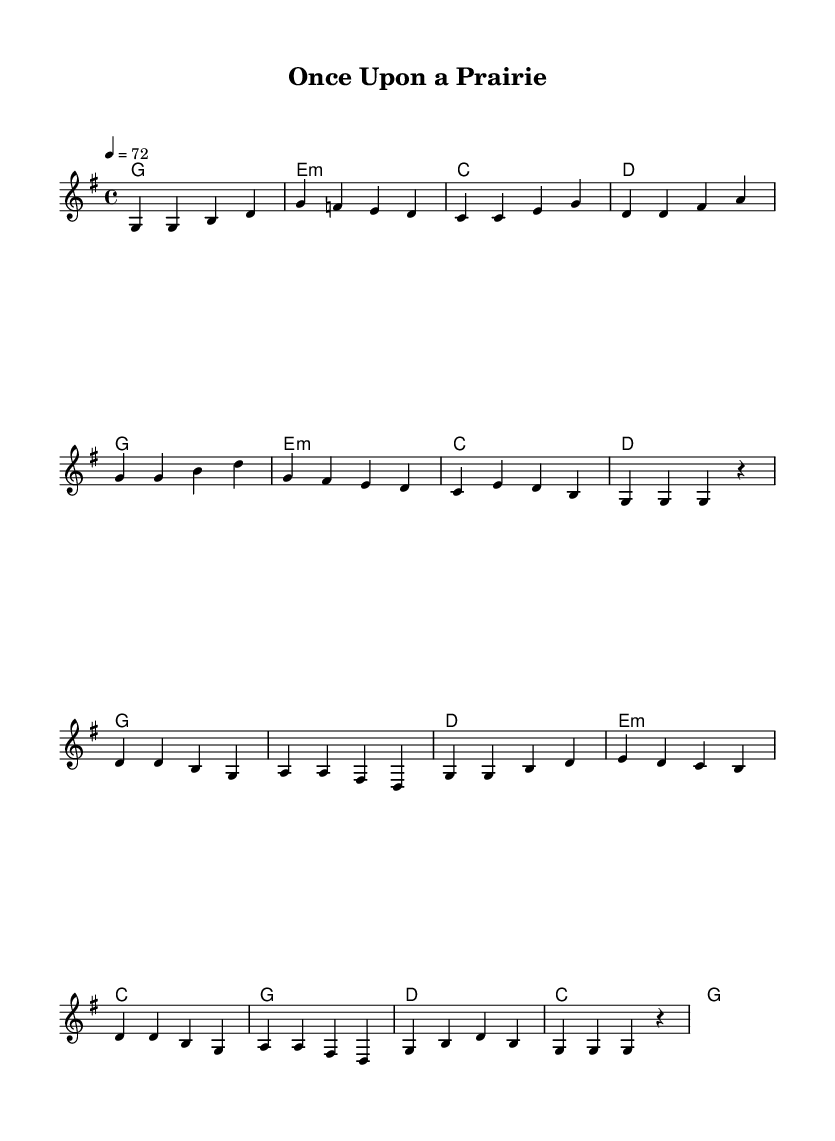What is the key signature of this music? The key signature indicates that this piece is in G major, which has one sharp, F#. This can be determined by looking at the key signature at the beginning of the music.
Answer: G major What is the time signature of this piece? The time signature shown at the beginning of the score is 4/4, meaning there are four beats in each measure and the quarter note gets one beat.
Answer: 4/4 What is the tempo marking for this composition? The tempo marking at the beginning specifies "4 = 72," which indicates that the quarter note should be played at a speed of 72 beats per minute.
Answer: 72 How many measures are in the verse? By counting the measures labeled under the melody section specifically for the verse, there are eight measures total. This is confirmed by observing the grouping of notes.
Answer: 8 What chords are used in the chorus? The chords for the chorus are G, D, E minor, and C. These can be identified in the chord section corresponding with the melody notes during the chorus line.
Answer: G, D, E minor, C What is the highest note in the melody? The highest note in the melody is D in the octave marked in the score. This can be confirmed by analyzing the melodic line's highest pitch throughout the piece.
Answer: D What type of song does this score represent? This score represents a gentle country ballad, influenced by children's literature and fairy tales, indicated by its melodic simplicity and thematic content.
Answer: Gentle country ballad 